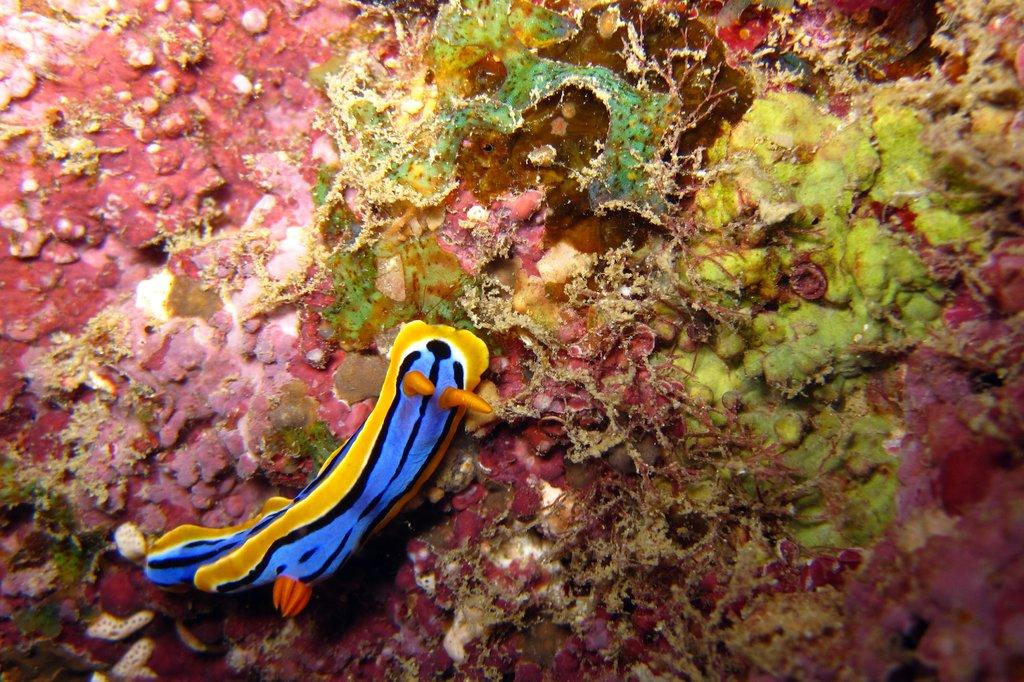What type of animal is in the image? There is a snail in the image. What can be seen in the background of the image? There are sea plants in the background of the image. What type of furniture is visible in the image? There is no furniture present in the image; it features a snail and sea plants. Can you describe how the snail runs in the image? Snails do not run; they move slowly using their muscular foot. However, in the image, the snail is not moving at all, as it is a still image. 